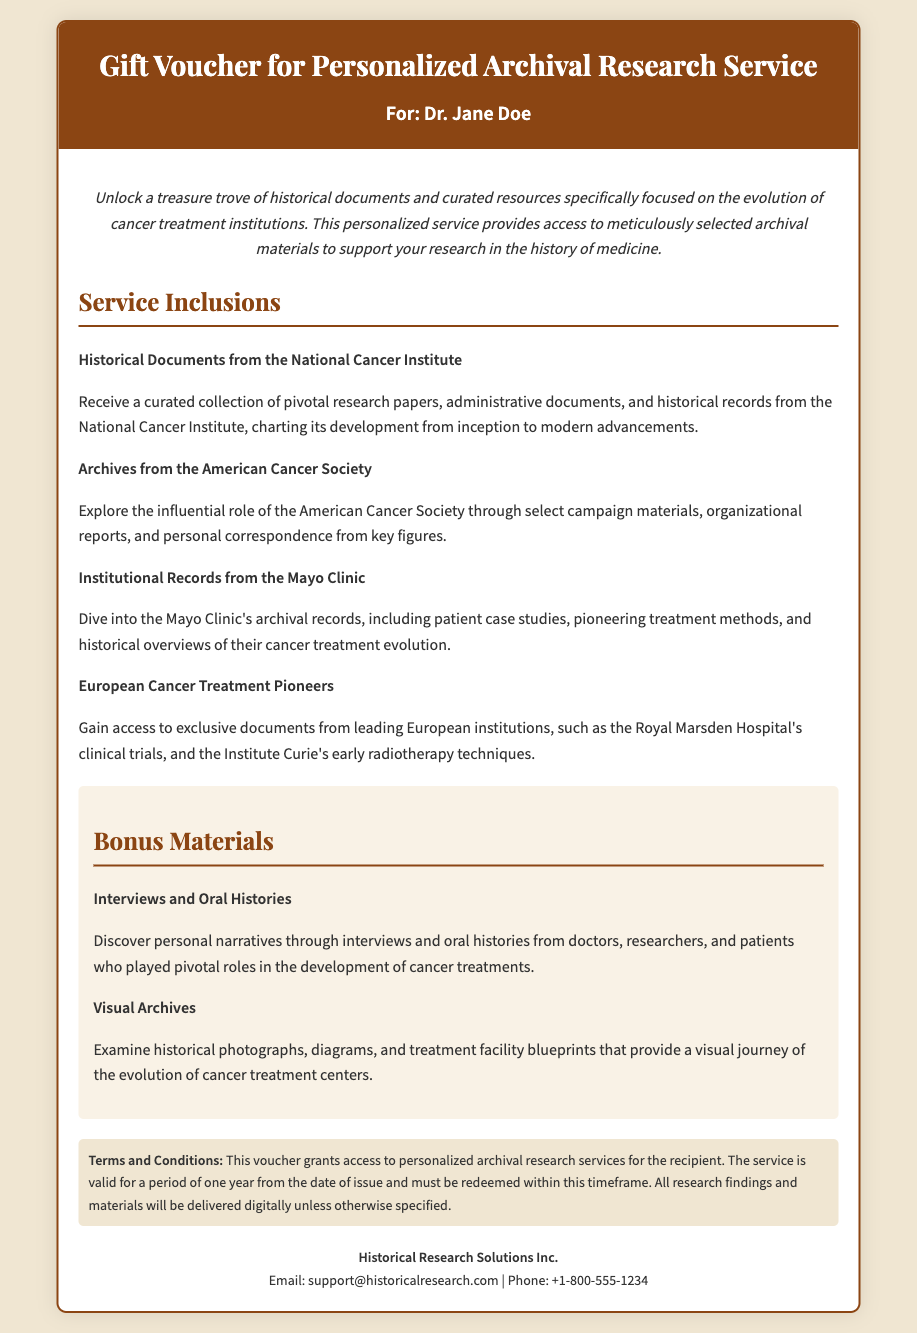what is the title of the document? The title is found in the header section of the document.
Answer: Gift Voucher for Personalized Archival Research Service who is the recipient of the voucher? The recipient's name is displayed right below the title.
Answer: Dr. Jane Doe what type of service is provided? The service type is described in the introductory paragraph.
Answer: Archival research service how long is the service valid? The validity period is specified in the terms and conditions.
Answer: One year which organization provides historical documents from the National Cancer Institute? This organization is mentioned within the service inclusions.
Answer: National Cancer Institute what unique feature is included as bonus materials? The unique feature is listed in the bonus materials section.
Answer: Interviews and Oral Histories how many service items are listed under "Service Inclusions"? This can be calculated by counting the items under this heading in the document.
Answer: Four what is the email address for Historical Research Solutions Inc.? The email address is provided in the contact section of the document.
Answer: support@historicalresearch.com what color is the header background? The header background color is indicated by the style in the document.
Answer: #8b4513 